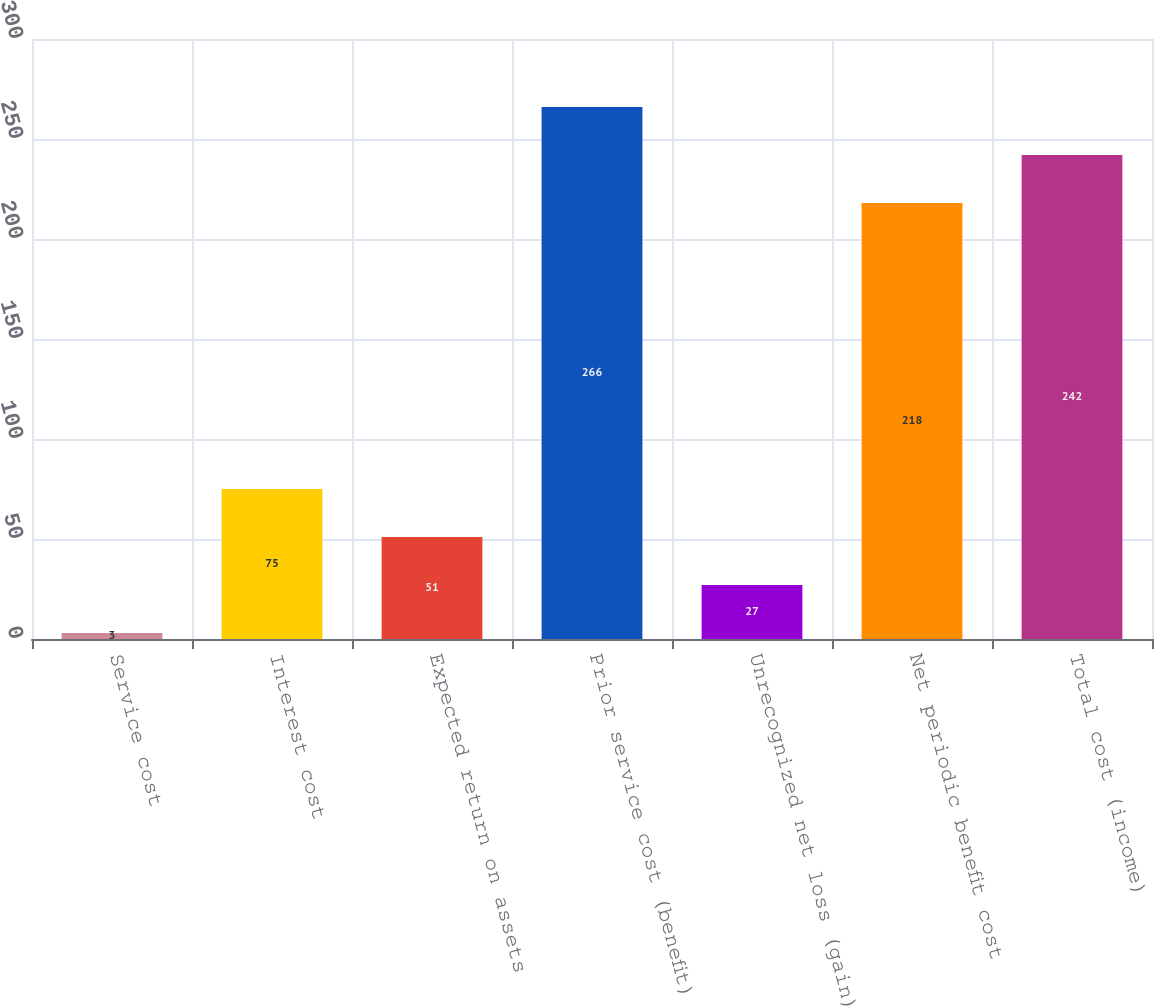Convert chart to OTSL. <chart><loc_0><loc_0><loc_500><loc_500><bar_chart><fcel>Service cost<fcel>Interest cost<fcel>Expected return on assets<fcel>Prior service cost (benefit)<fcel>Unrecognized net loss (gain)<fcel>Net periodic benefit cost<fcel>Total cost (income)<nl><fcel>3<fcel>75<fcel>51<fcel>266<fcel>27<fcel>218<fcel>242<nl></chart> 